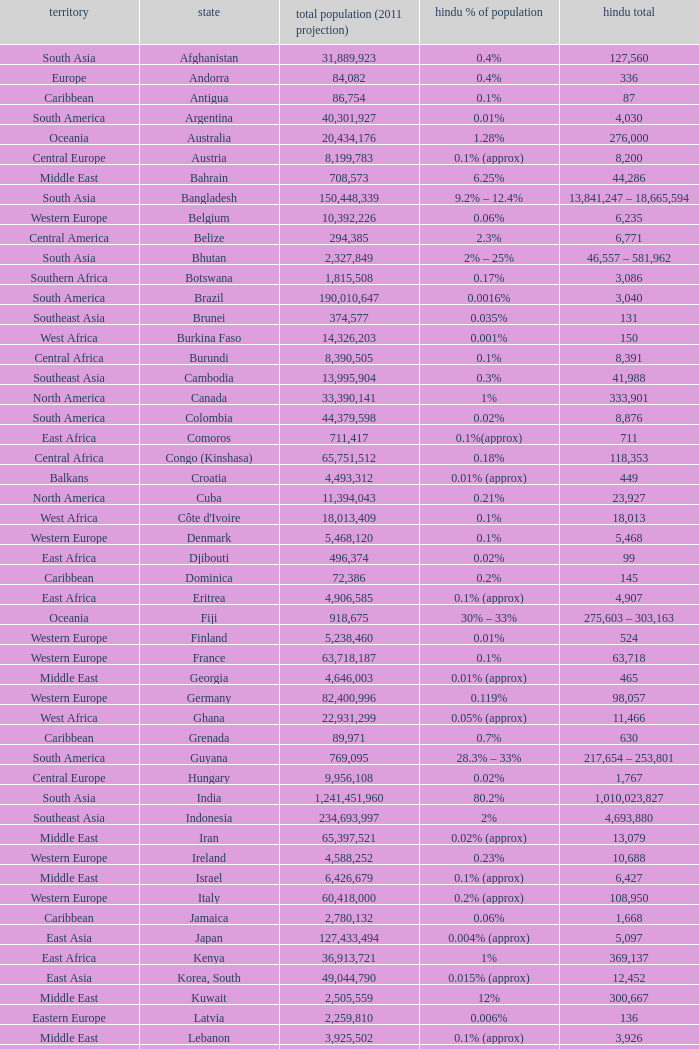Total Population (2011 est) larger than 30,262,610, and a Hindu total of 63,718 involves what country? France. 